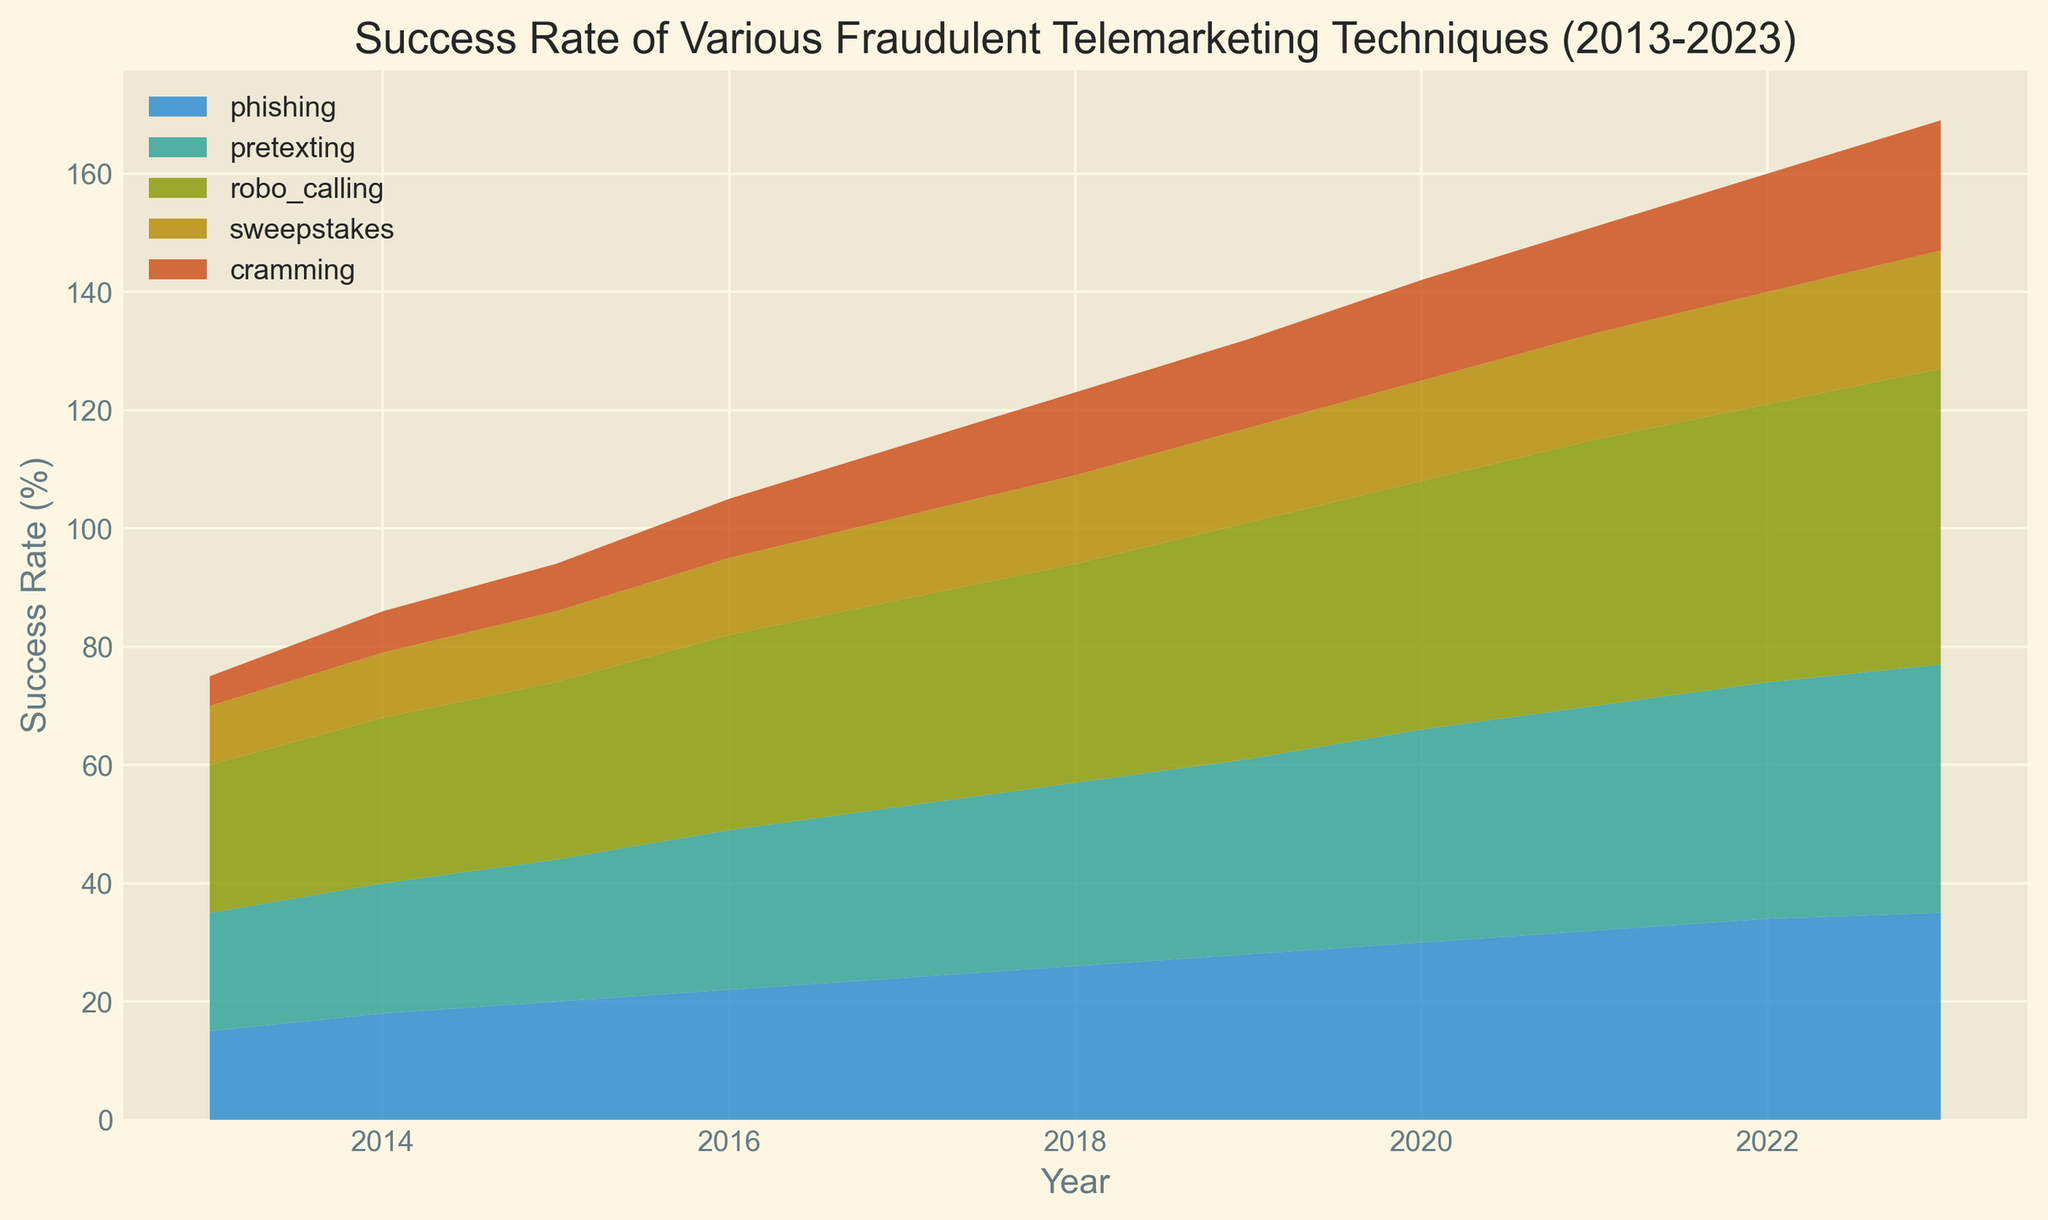Which fraudulent telemarketing technique had the highest success rate in 2023? By the end of the chart data (2023), the technique with the highest peak area represents the highest success rate.
Answer: robo_calling How much did the success rate of phishing increase from 2013 to 2023? The success rate of phishing in 2013 was 15%, and in 2023 it is 35%. The increase is 35% - 15% = 20%.
Answer: 20% Which technique saw the largest overall increase in success rate over the decade? To determine which technique saw the largest increase, look at the difference in success rate between 2023 and 2013 for each technique. Robo calling increased from 25% to 50%, which is the largest increase.
Answer: robo_calling Compare the success rates of sweeping and cramming techniques in 2015. Which one had a higher success rate? In 2015, sweepstakes had a success rate of 12% and cramming had a success rate of 8%. Sweepstakes was higher.
Answer: sweepstakes What was the combined success rate of phishing and pretexting in 2020? The success rate of phishing in 2020 was 30%, and pretexting was 36%. Summing these gives a combined success rate of 30% + 36% = 66%.
Answer: 66% Between what years did pretexting see the highest rate of increase in success? To find when pretexting grew the fastest, look for the steepest incline in the area representing pretexting. The steepest growth is from 2019 to 2020.
Answer: 2019 to 2020 How does the success rate of cramming in 2019 compare to cramming in 2020? In 2019, cramming had a success rate of 15%, and it increased to 17% in 2020. The success rate increased by 2%.
Answer: 2% Which technique showed a constant positive trend throughout the decade? By observing the overall trends, the success rates of all techniques increased, but phishing, pretexting, robo calling, sweepstakes, and cramming all showed consistent positive trends.
Answer: All techniques By how much did the total success rate of all techniques change from 2013 to 2023? Sum up the success rates of all techniques for 2013 and 2023. In 2013: 15 + 20 + 25 + 10 + 5 = 75%. In 2023: 35 + 42 + 50 + 20 + 22 = 169%. The change is 169% - 75% = 94%.
Answer: 94% Which technique had the smallest success rate difference between any two consecutive years? To find the smallest difference, examine the change for each year sequence in success rate per technique. Cramming trends show some of the smallest year-over-year change between many points, especially 2019-2020 with just 2%.
Answer: cramming 